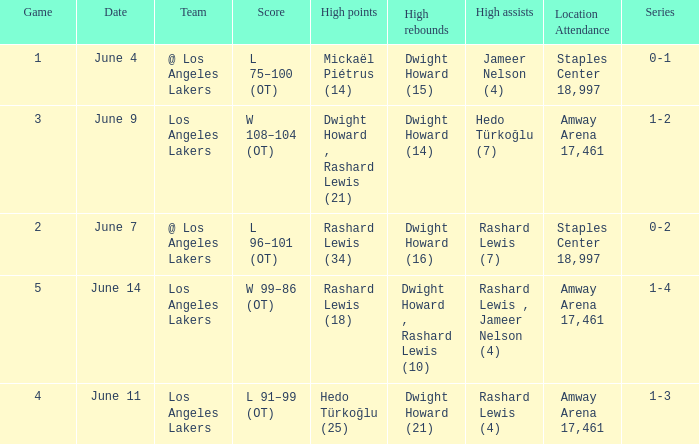What is Team, when High Assists is "Rashard Lewis (4)"? Los Angeles Lakers. 